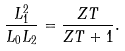<formula> <loc_0><loc_0><loc_500><loc_500>\frac { L _ { 1 } ^ { 2 } } { L _ { 0 } L _ { 2 } } = \frac { Z T } { Z T + 1 } .</formula> 